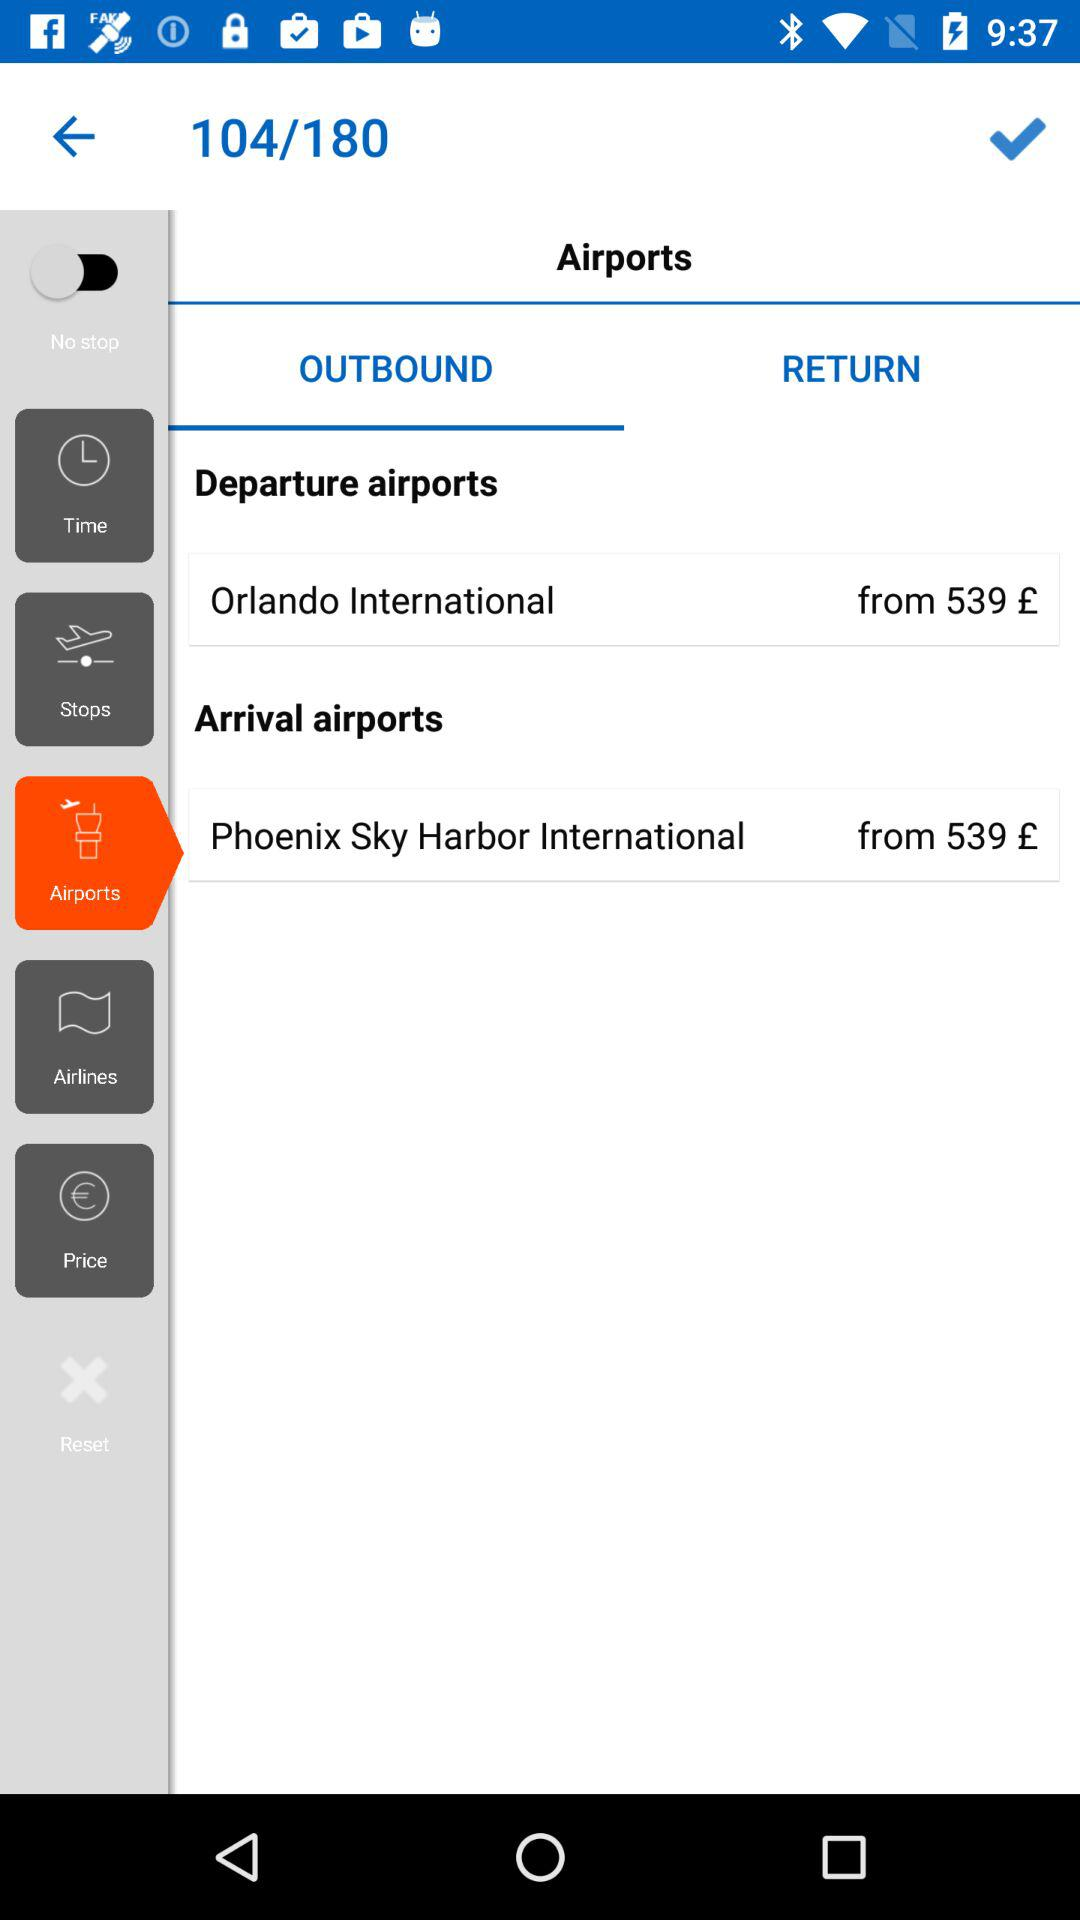What is the selected option? The selected options are "Airports" and "OUTBOUND". 